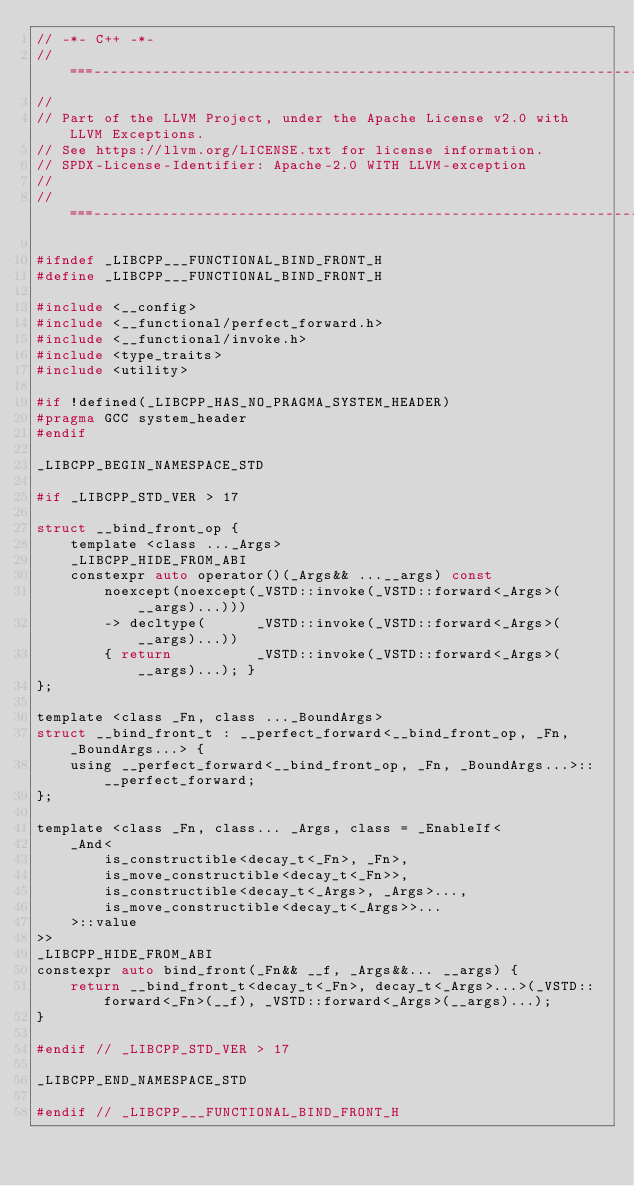Convert code to text. <code><loc_0><loc_0><loc_500><loc_500><_C_>// -*- C++ -*-
//===----------------------------------------------------------------------===//
//
// Part of the LLVM Project, under the Apache License v2.0 with LLVM Exceptions.
// See https://llvm.org/LICENSE.txt for license information.
// SPDX-License-Identifier: Apache-2.0 WITH LLVM-exception
//
//===----------------------------------------------------------------------===//

#ifndef _LIBCPP___FUNCTIONAL_BIND_FRONT_H
#define _LIBCPP___FUNCTIONAL_BIND_FRONT_H

#include <__config>
#include <__functional/perfect_forward.h>
#include <__functional/invoke.h>
#include <type_traits>
#include <utility>

#if !defined(_LIBCPP_HAS_NO_PRAGMA_SYSTEM_HEADER)
#pragma GCC system_header
#endif

_LIBCPP_BEGIN_NAMESPACE_STD

#if _LIBCPP_STD_VER > 17

struct __bind_front_op {
    template <class ..._Args>
    _LIBCPP_HIDE_FROM_ABI
    constexpr auto operator()(_Args&& ...__args) const
        noexcept(noexcept(_VSTD::invoke(_VSTD::forward<_Args>(__args)...)))
        -> decltype(      _VSTD::invoke(_VSTD::forward<_Args>(__args)...))
        { return          _VSTD::invoke(_VSTD::forward<_Args>(__args)...); }
};

template <class _Fn, class ..._BoundArgs>
struct __bind_front_t : __perfect_forward<__bind_front_op, _Fn, _BoundArgs...> {
    using __perfect_forward<__bind_front_op, _Fn, _BoundArgs...>::__perfect_forward;
};

template <class _Fn, class... _Args, class = _EnableIf<
    _And<
        is_constructible<decay_t<_Fn>, _Fn>,
        is_move_constructible<decay_t<_Fn>>,
        is_constructible<decay_t<_Args>, _Args>...,
        is_move_constructible<decay_t<_Args>>...
    >::value
>>
_LIBCPP_HIDE_FROM_ABI
constexpr auto bind_front(_Fn&& __f, _Args&&... __args) {
    return __bind_front_t<decay_t<_Fn>, decay_t<_Args>...>(_VSTD::forward<_Fn>(__f), _VSTD::forward<_Args>(__args)...);
}

#endif // _LIBCPP_STD_VER > 17

_LIBCPP_END_NAMESPACE_STD

#endif // _LIBCPP___FUNCTIONAL_BIND_FRONT_H
</code> 